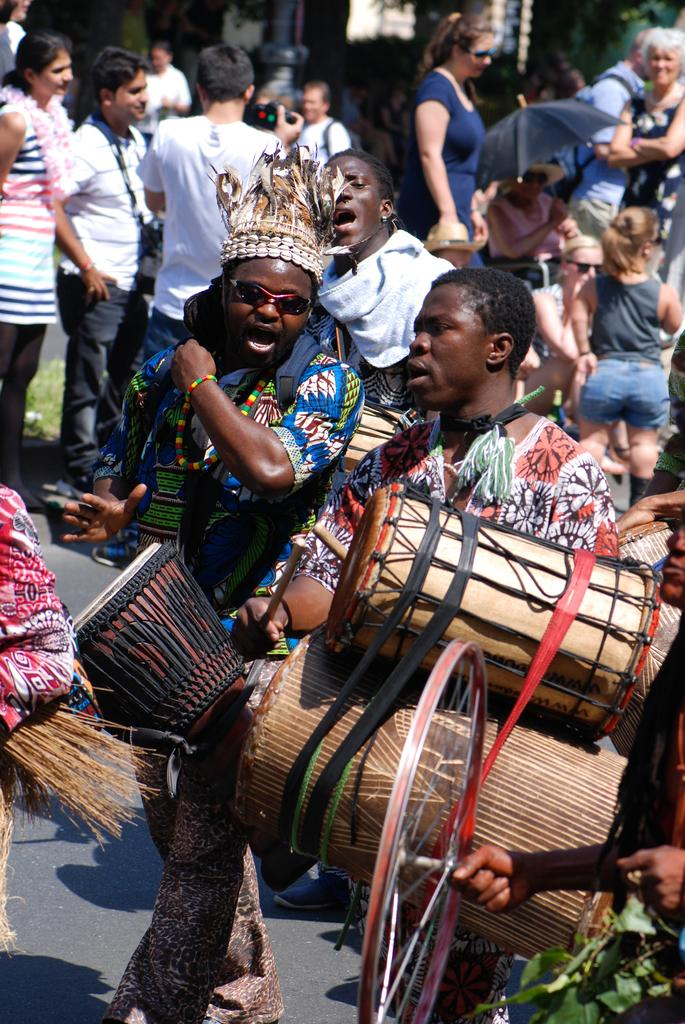What is happening in the image? There are people standing in the image. Can you describe what one of the people is holding? A man is holding musical drums in the image. What type of cloth is draped over the downtown area in the image? There is no cloth draped over the downtown area in the image, as there is no downtown area or cloth mentioned in the facts. 